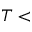<formula> <loc_0><loc_0><loc_500><loc_500>T <</formula> 